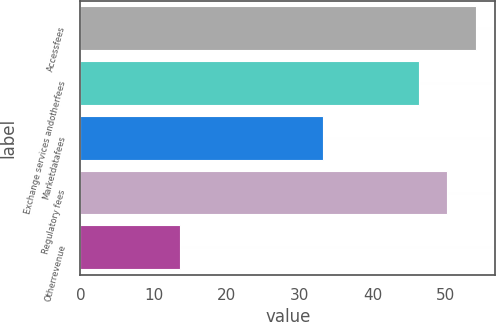<chart> <loc_0><loc_0><loc_500><loc_500><bar_chart><fcel>Accessfees<fcel>Exchange services andotherfees<fcel>Marketdatafees<fcel>Regulatory fees<fcel>Otherrevenue<nl><fcel>54.06<fcel>46.3<fcel>33.2<fcel>50.18<fcel>13.6<nl></chart> 